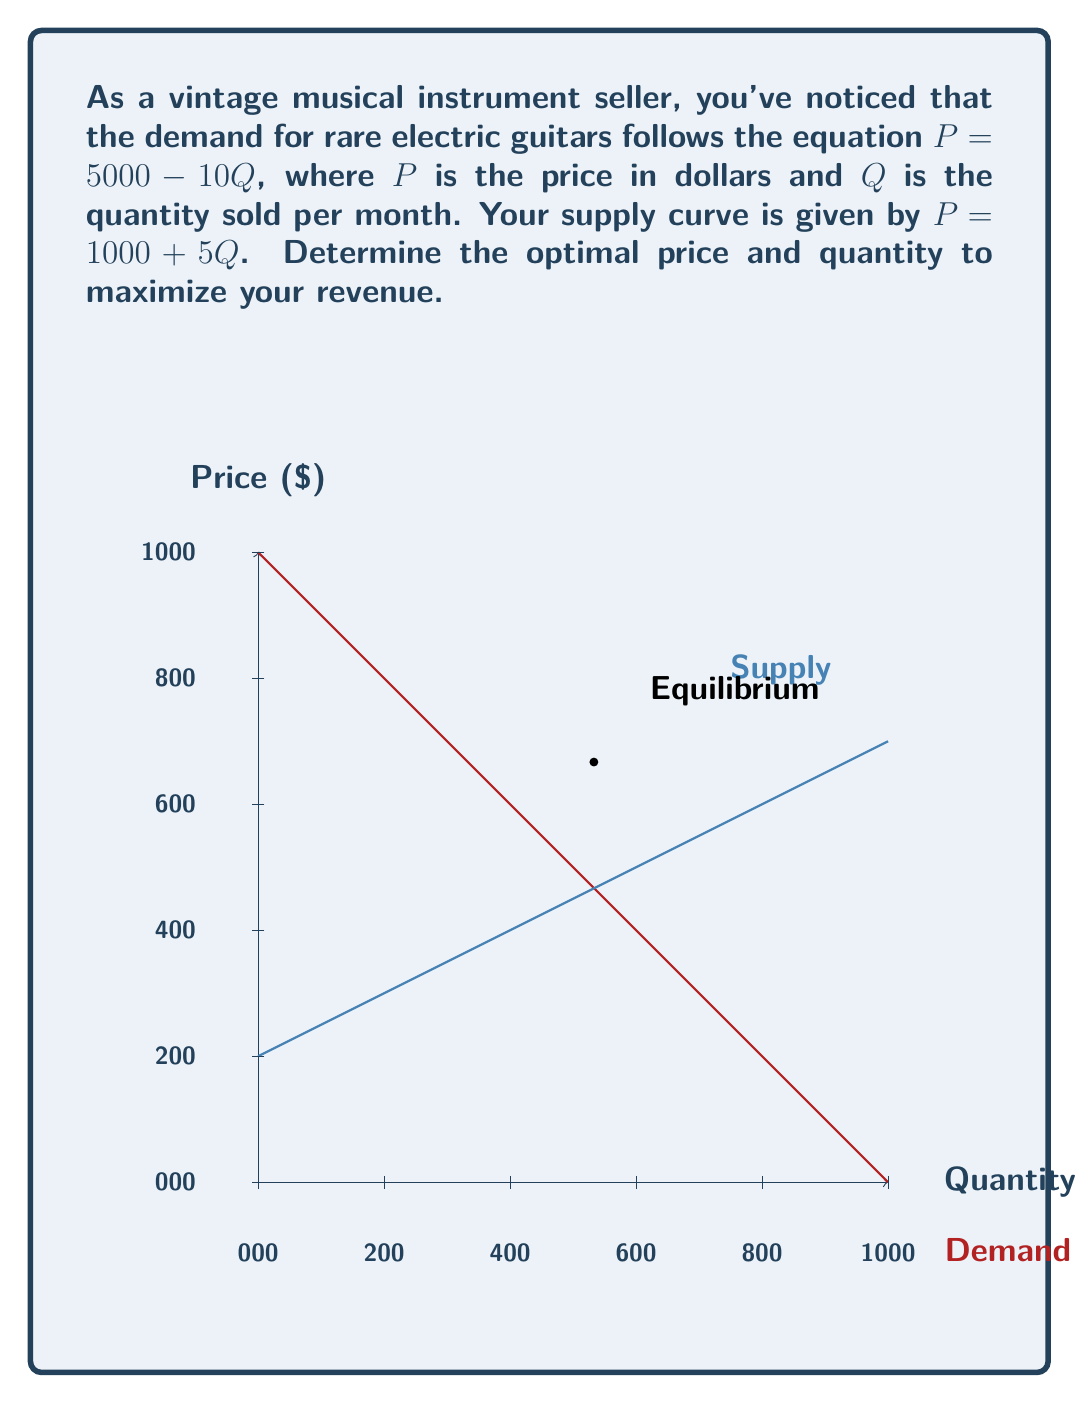Give your solution to this math problem. Let's approach this step-by-step:

1) The equilibrium point is where supply equals demand. We can find this by equating the two equations:

   $5000 - 10Q = 1000 + 5Q$

2) Solve for Q:
   $4000 = 15Q$
   $Q = 266.67$

3) To find the equilibrium price, substitute this Q into either equation. Let's use the demand equation:

   $P = 5000 - 10(266.67) = 3333.33$

4) The equilibrium point is (266.67, 3333.33).

5) To maximize revenue, we need to find the point where Marginal Revenue (MR) equals Marginal Cost (MC).

6) The demand function is $P = 5000 - 10Q$
   Total Revenue (TR) = $P * Q = (5000 - 10Q) * Q = 5000Q - 10Q^2$
   Marginal Revenue (MR) = $\frac{d(TR)}{dQ} = 5000 - 20Q$

7) The supply function is $P = 1000 + 5Q$, which represents the Marginal Cost (MC).

8) Set MR = MC:
   $5000 - 20Q = 1000 + 5Q$
   $4000 = 25Q$
   $Q = 160$

9) To find the optimal price, substitute Q = 160 into the demand equation:
   $P = 5000 - 10(160) = 3400$

Therefore, the optimal price is $3400 and the optimal quantity is 160 guitars per month.
Answer: $3400, 160 